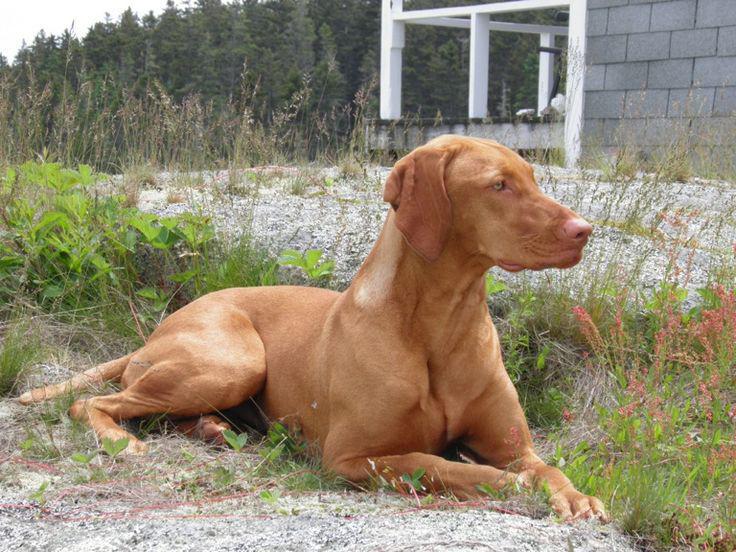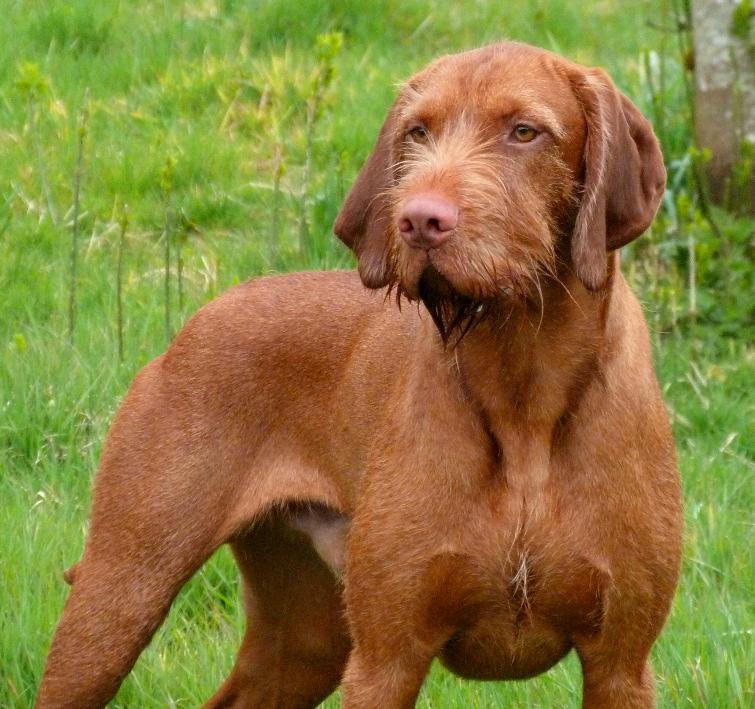The first image is the image on the left, the second image is the image on the right. Examine the images to the left and right. Is the description "The left image includes a puppy sitting upright and facing forward, and the right image contains one dog in a reclining pose on grass, with its head facing forward." accurate? Answer yes or no. No. 